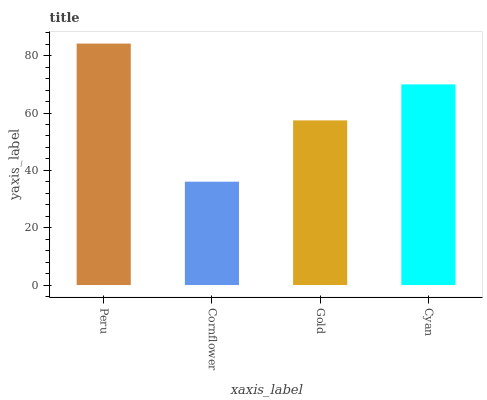Is Gold the minimum?
Answer yes or no. No. Is Gold the maximum?
Answer yes or no. No. Is Gold greater than Cornflower?
Answer yes or no. Yes. Is Cornflower less than Gold?
Answer yes or no. Yes. Is Cornflower greater than Gold?
Answer yes or no. No. Is Gold less than Cornflower?
Answer yes or no. No. Is Cyan the high median?
Answer yes or no. Yes. Is Gold the low median?
Answer yes or no. Yes. Is Gold the high median?
Answer yes or no. No. Is Peru the low median?
Answer yes or no. No. 